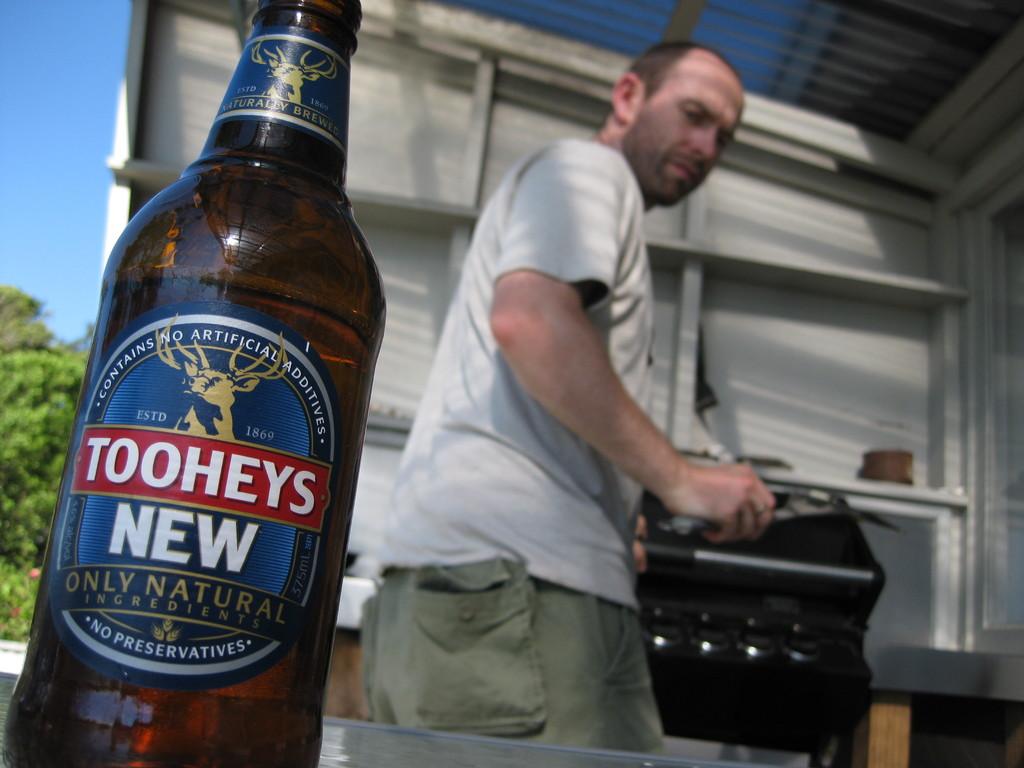Is this a bottle of toohey's?
Provide a succinct answer. Yes. What brand of beer is this?
Your answer should be compact. Tooheys new. 